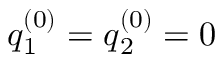Convert formula to latex. <formula><loc_0><loc_0><loc_500><loc_500>q _ { 1 } ^ { ( 0 ) } = q _ { 2 } ^ { ( 0 ) } = 0</formula> 